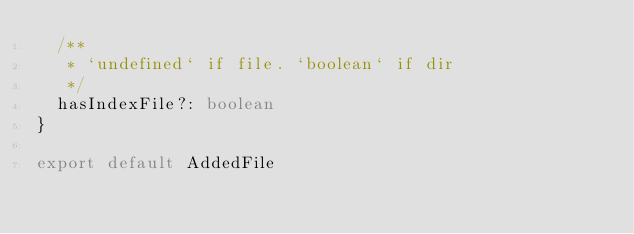<code> <loc_0><loc_0><loc_500><loc_500><_TypeScript_>  /**
   * `undefined` if file. `boolean` if dir
   */
  hasIndexFile?: boolean
}

export default AddedFile
</code> 